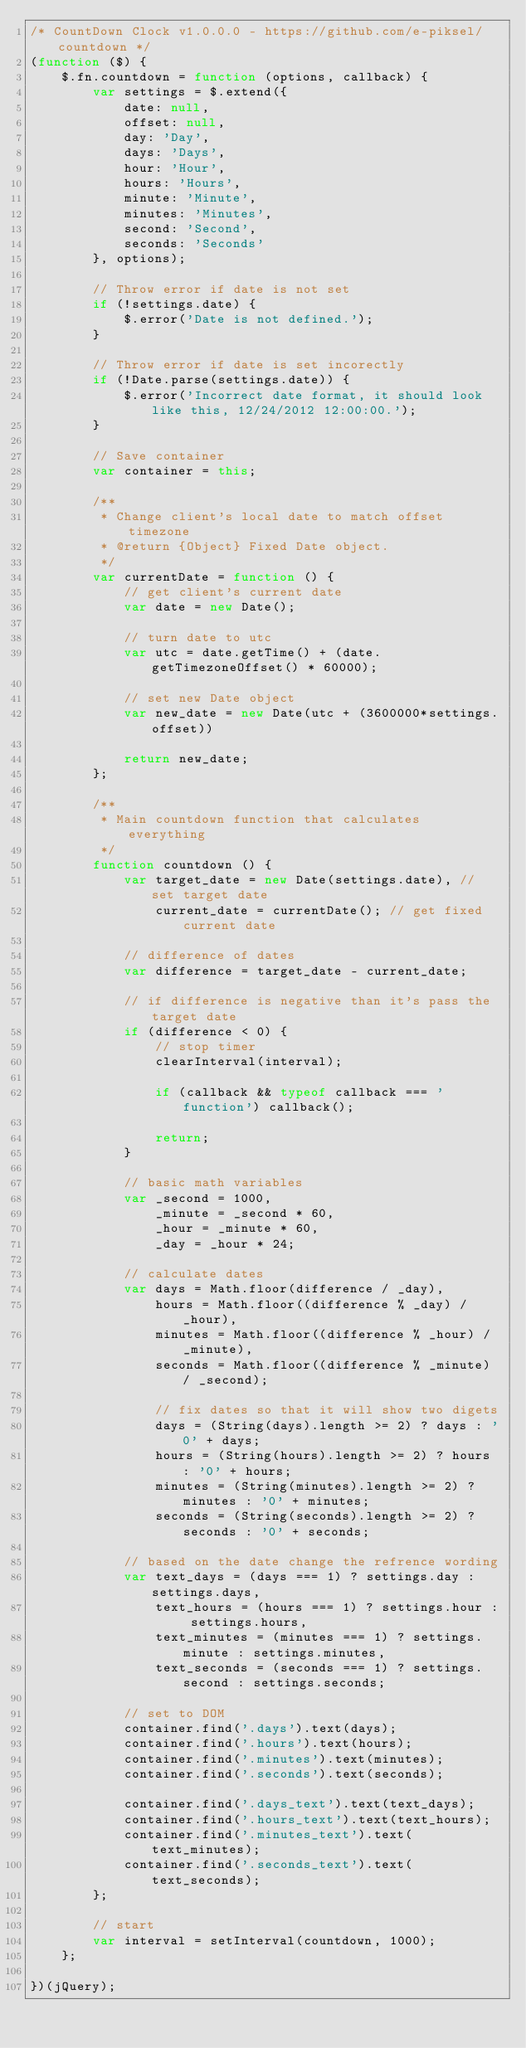<code> <loc_0><loc_0><loc_500><loc_500><_JavaScript_>/* CountDown Clock v1.0.0.0 - https://github.com/e-piksel/countdown */
(function ($) {
	$.fn.countdown = function (options, callback) {
		var settings = $.extend({
			date: null,
			offset: null,
			day: 'Day',
			days: 'Days',
			hour: 'Hour',
			hours: 'Hours',
			minute: 'Minute',
			minutes: 'Minutes',
			second: 'Second',
			seconds: 'Seconds'
		}, options);

		// Throw error if date is not set
		if (!settings.date) {
			$.error('Date is not defined.');
		}

		// Throw error if date is set incorectly
		if (!Date.parse(settings.date)) {
			$.error('Incorrect date format, it should look like this, 12/24/2012 12:00:00.');
		}

		// Save container
		var container = this;

		/**
		 * Change client's local date to match offset timezone
		 * @return {Object} Fixed Date object.
		 */
		var currentDate = function () {
			// get client's current date
			var date = new Date();

			// turn date to utc
			var utc = date.getTime() + (date.getTimezoneOffset() * 60000);

			// set new Date object
			var new_date = new Date(utc + (3600000*settings.offset))

			return new_date;
		};

		/**
		 * Main countdown function that calculates everything
		 */
		function countdown () {
			var target_date = new Date(settings.date), // set target date
				current_date = currentDate(); // get fixed current date

			// difference of dates
			var difference = target_date - current_date;

			// if difference is negative than it's pass the target date
			if (difference < 0) {
				// stop timer
				clearInterval(interval);

				if (callback && typeof callback === 'function') callback();

				return;
			}

			// basic math variables
			var _second = 1000,
				_minute = _second * 60,
				_hour = _minute * 60,
				_day = _hour * 24;

			// calculate dates
			var days = Math.floor(difference / _day),
				hours = Math.floor((difference % _day) / _hour),
				minutes = Math.floor((difference % _hour) / _minute),
				seconds = Math.floor((difference % _minute) / _second);

				// fix dates so that it will show two digets
				days = (String(days).length >= 2) ? days : '0' + days;
				hours = (String(hours).length >= 2) ? hours : '0' + hours;
				minutes = (String(minutes).length >= 2) ? minutes : '0' + minutes;
				seconds = (String(seconds).length >= 2) ? seconds : '0' + seconds;

			// based on the date change the refrence wording
			var text_days = (days === 1) ? settings.day : settings.days,
				text_hours = (hours === 1) ? settings.hour : settings.hours,
				text_minutes = (minutes === 1) ? settings.minute : settings.minutes,
				text_seconds = (seconds === 1) ? settings.second : settings.seconds;

			// set to DOM
			container.find('.days').text(days);
			container.find('.hours').text(hours);
			container.find('.minutes').text(minutes);
			container.find('.seconds').text(seconds);

			container.find('.days_text').text(text_days);
			container.find('.hours_text').text(text_hours);
			container.find('.minutes_text').text(text_minutes);
			container.find('.seconds_text').text(text_seconds);
		};
		
		// start
		var interval = setInterval(countdown, 1000);
	};

})(jQuery);</code> 